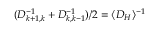<formula> <loc_0><loc_0><loc_500><loc_500>( D _ { k + 1 , k } ^ { - 1 } + D _ { k , k - 1 } ^ { - 1 } ) / 2 = \langle D _ { H } \rangle ^ { - 1 }</formula> 